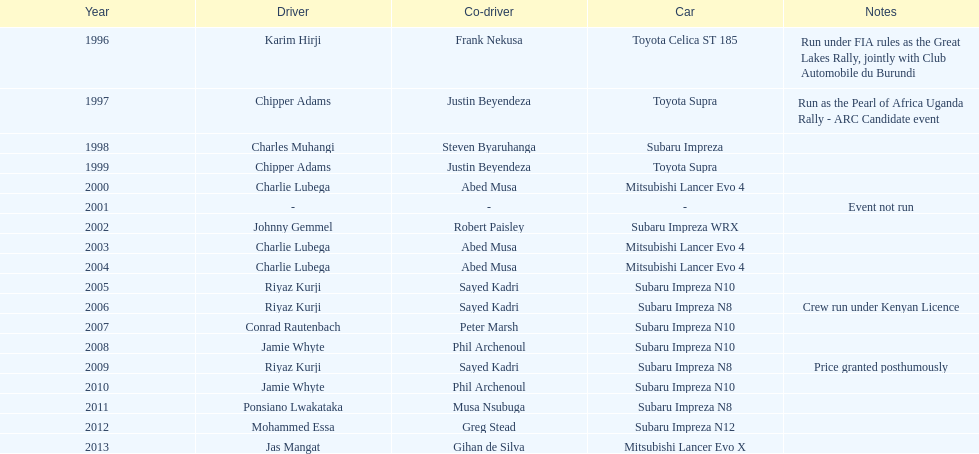How frequently did charlie lubega function as a driver? 3. 